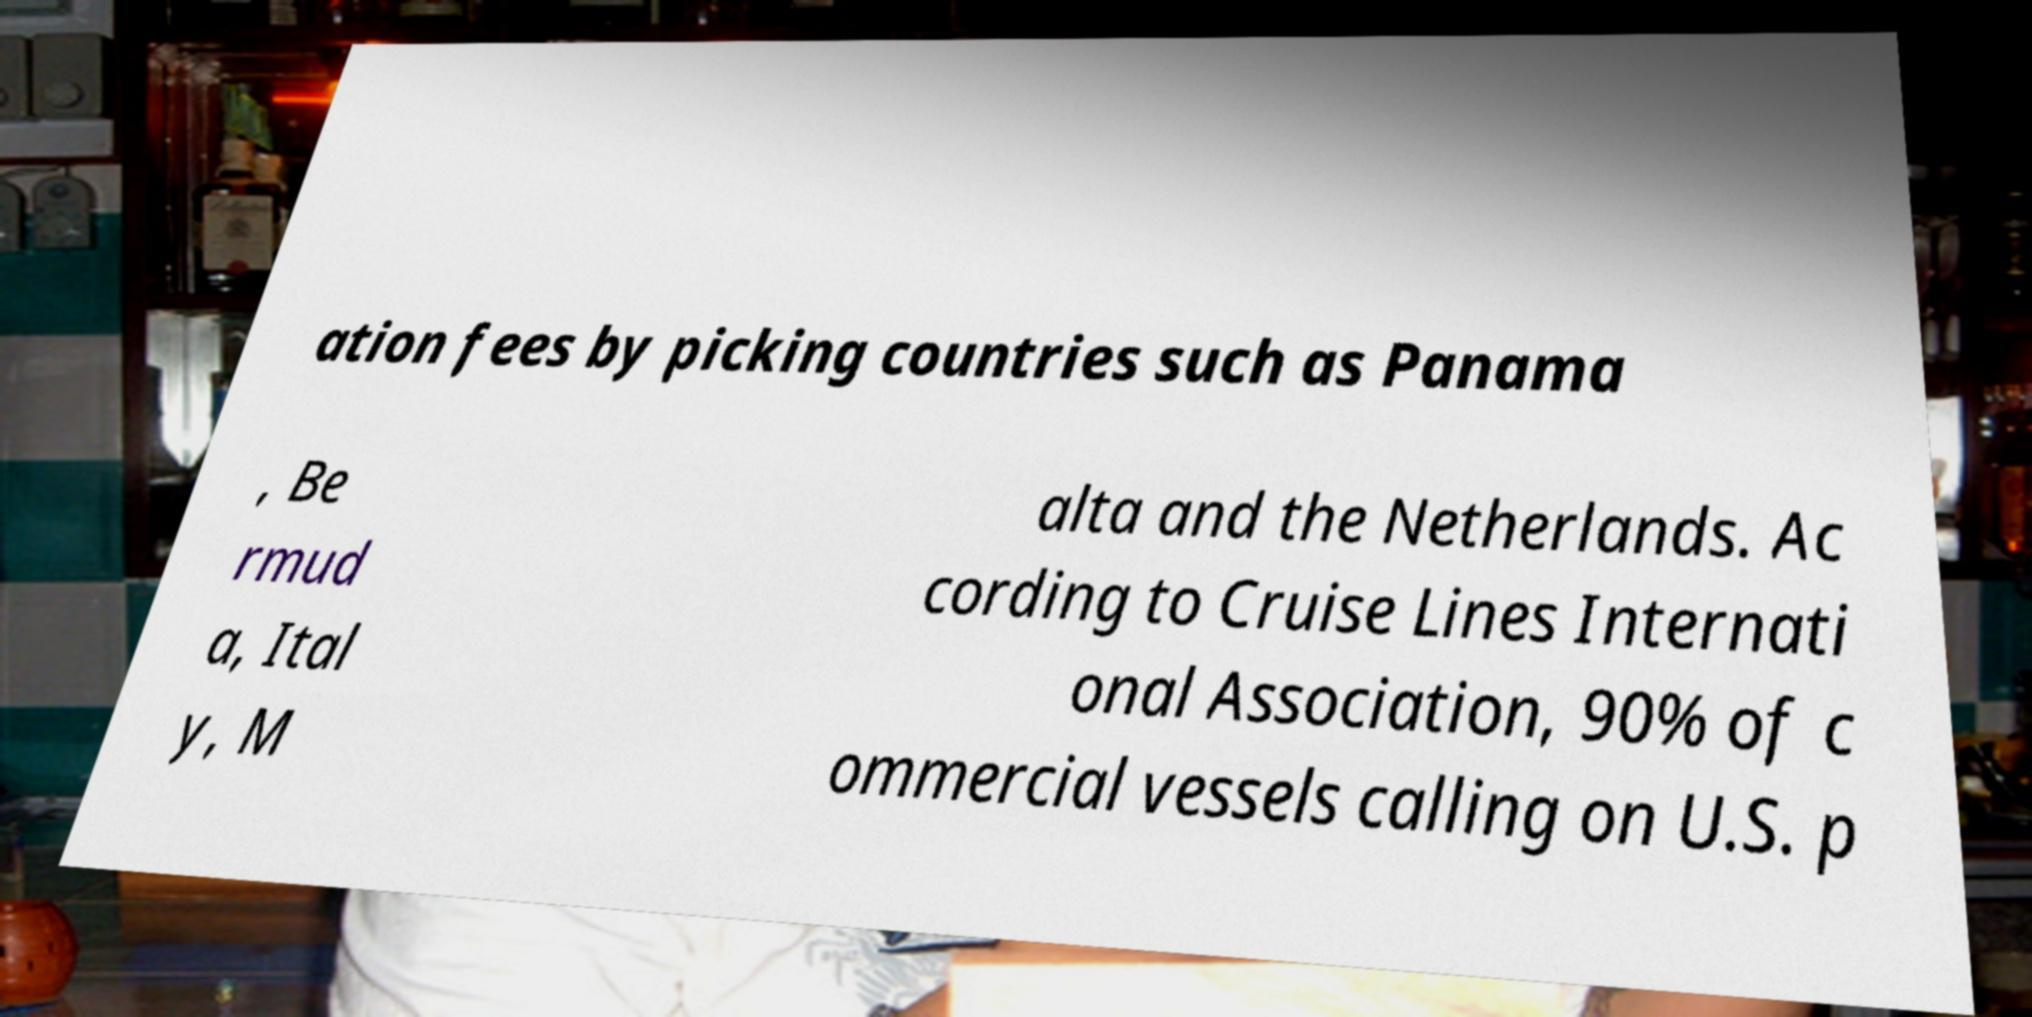What messages or text are displayed in this image? I need them in a readable, typed format. ation fees by picking countries such as Panama , Be rmud a, Ital y, M alta and the Netherlands. Ac cording to Cruise Lines Internati onal Association, 90% of c ommercial vessels calling on U.S. p 